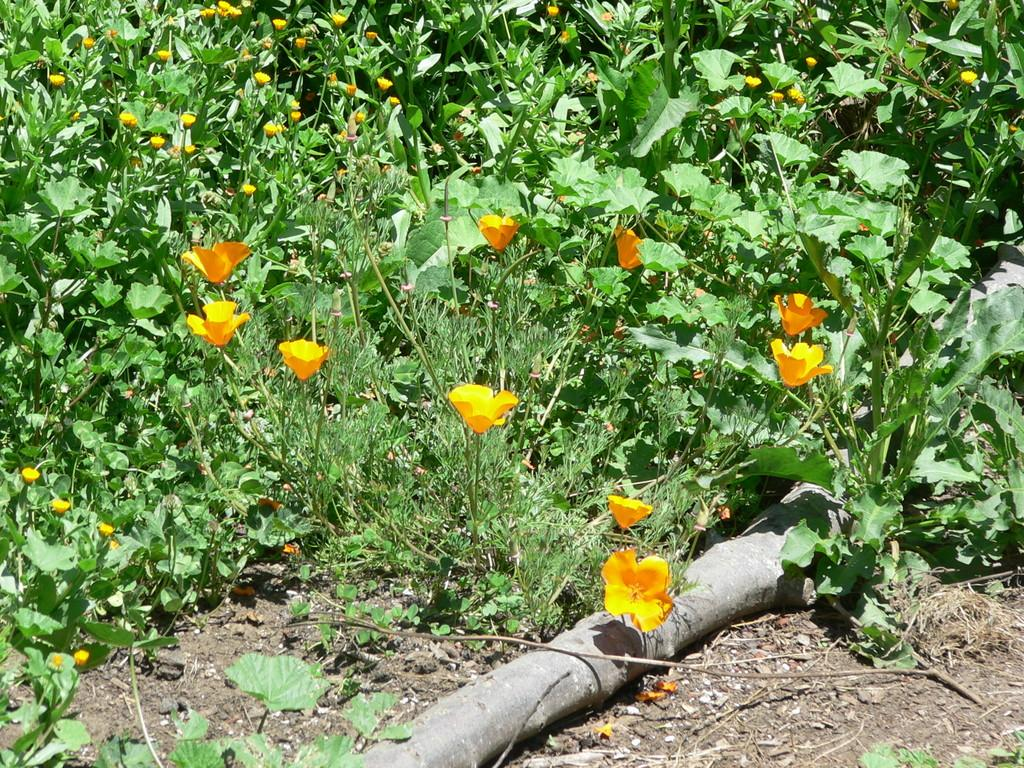What color are the flowers in the image? The flowers in the image are yellow. What are the flowers attached to? The flowers are on plants. What can be seen on the ground in the image? There is a pipe on the ground in the image. What type of land is visible in the image? There is no specific type of land mentioned or visible in the image; it only shows flowers, plants, and a pipe on the ground. 